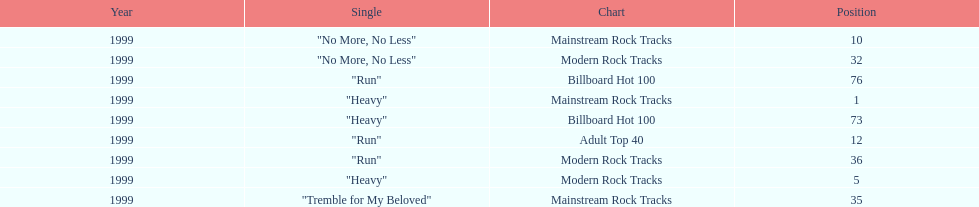Which of the singles from "dosage" had the highest billboard hot 100 rating? "Heavy". 